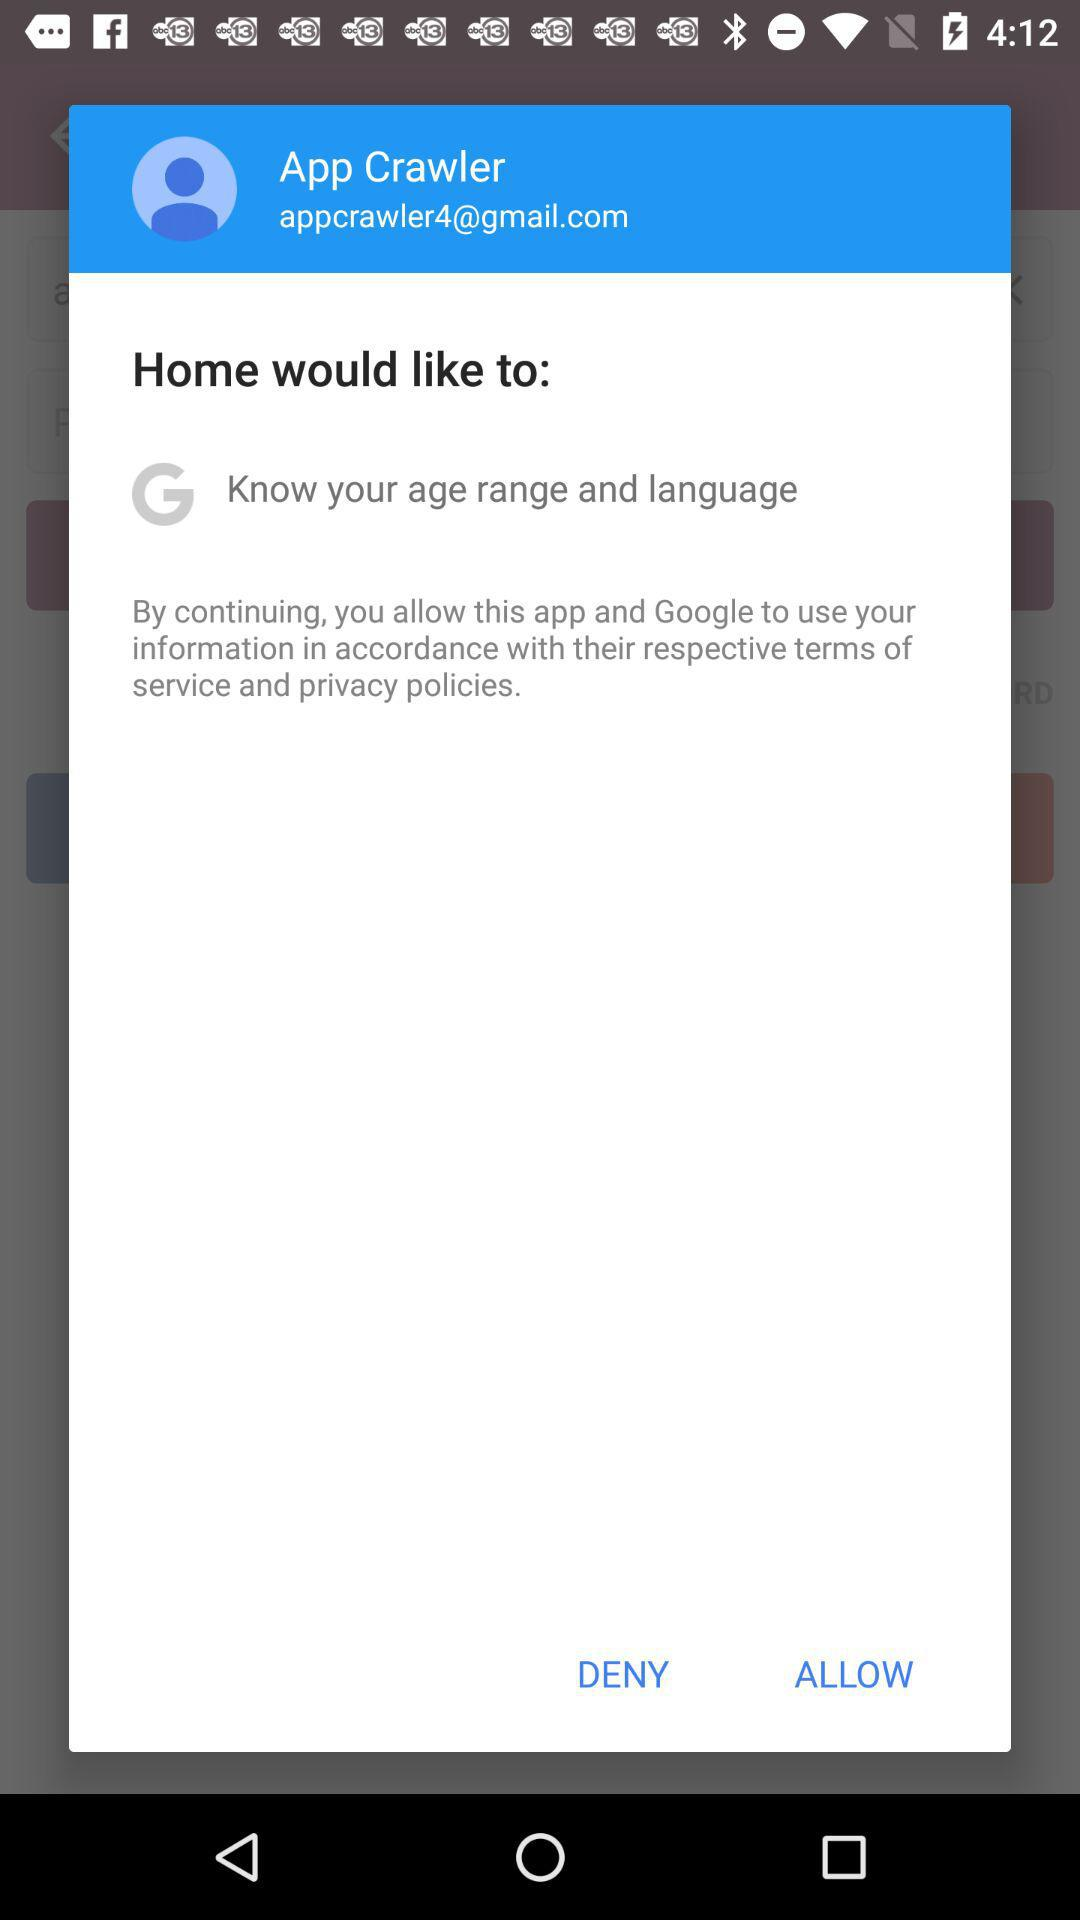What permissions is the app requesting from the user? The app is requesting permission to know the user's age range and language, as indicated on the screen. 